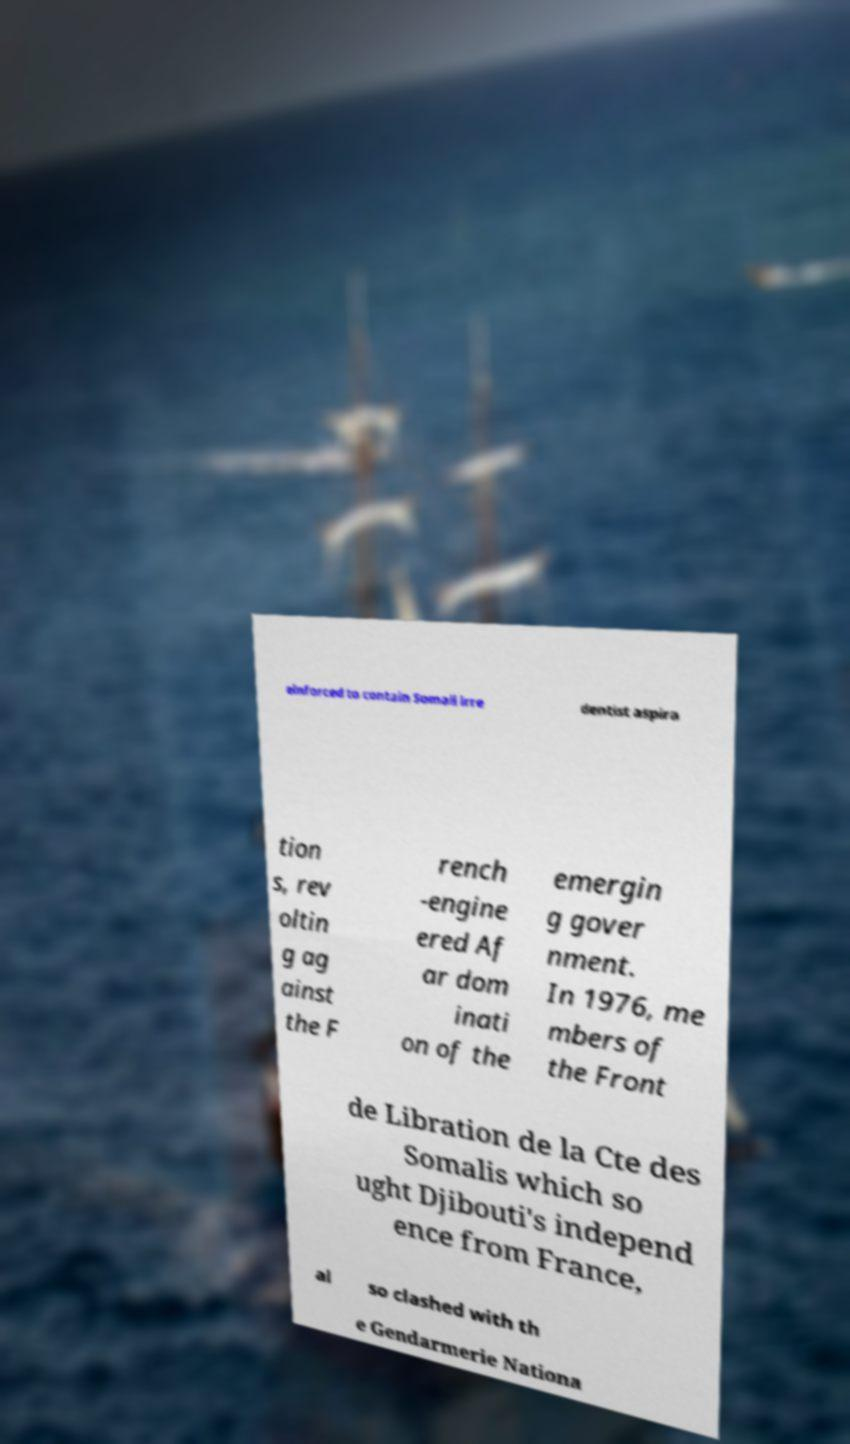Can you read and provide the text displayed in the image?This photo seems to have some interesting text. Can you extract and type it out for me? einforced to contain Somali irre dentist aspira tion s, rev oltin g ag ainst the F rench -engine ered Af ar dom inati on of the emergin g gover nment. In 1976, me mbers of the Front de Libration de la Cte des Somalis which so ught Djibouti's independ ence from France, al so clashed with th e Gendarmerie Nationa 